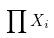<formula> <loc_0><loc_0><loc_500><loc_500>\prod X _ { i }</formula> 